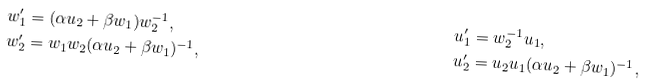<formula> <loc_0><loc_0><loc_500><loc_500>w _ { 1 } ^ { \prime } & = ( \alpha u _ { 2 } + \beta w _ { 1 } ) w _ { 2 } ^ { - 1 } , & u _ { 1 } ^ { \prime } & = w _ { 2 } ^ { - 1 } u _ { 1 } , \\ w _ { 2 } ^ { \prime } & = w _ { 1 } w _ { 2 } ( \alpha u _ { 2 } + \beta w _ { 1 } ) ^ { - 1 } , & u _ { 2 } ^ { \prime } & = u _ { 2 } u _ { 1 } ( \alpha u _ { 2 } + \beta w _ { 1 } ) ^ { - 1 } ,</formula> 